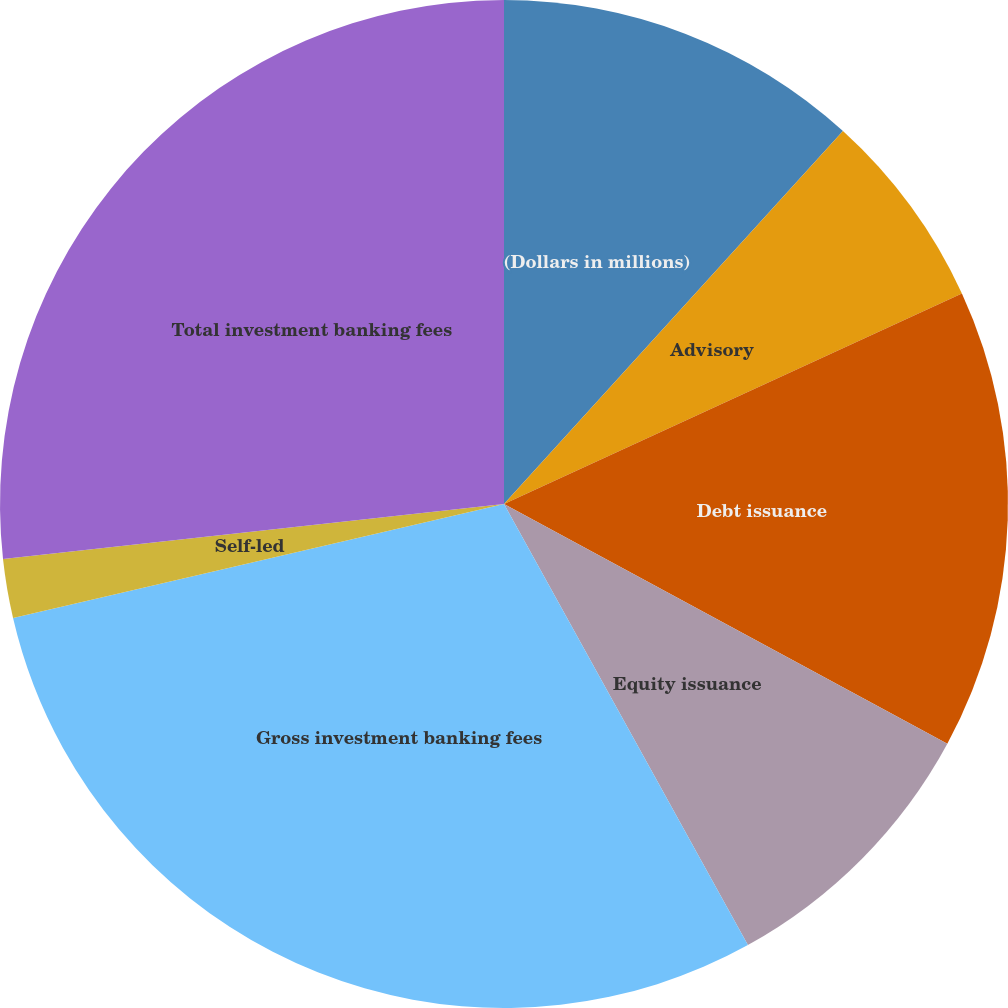<chart> <loc_0><loc_0><loc_500><loc_500><pie_chart><fcel>(Dollars in millions)<fcel>Advisory<fcel>Debt issuance<fcel>Equity issuance<fcel>Gross investment banking fees<fcel>Self-led<fcel>Total investment banking fees<nl><fcel>11.74%<fcel>6.4%<fcel>14.75%<fcel>9.07%<fcel>29.41%<fcel>1.89%<fcel>26.74%<nl></chart> 